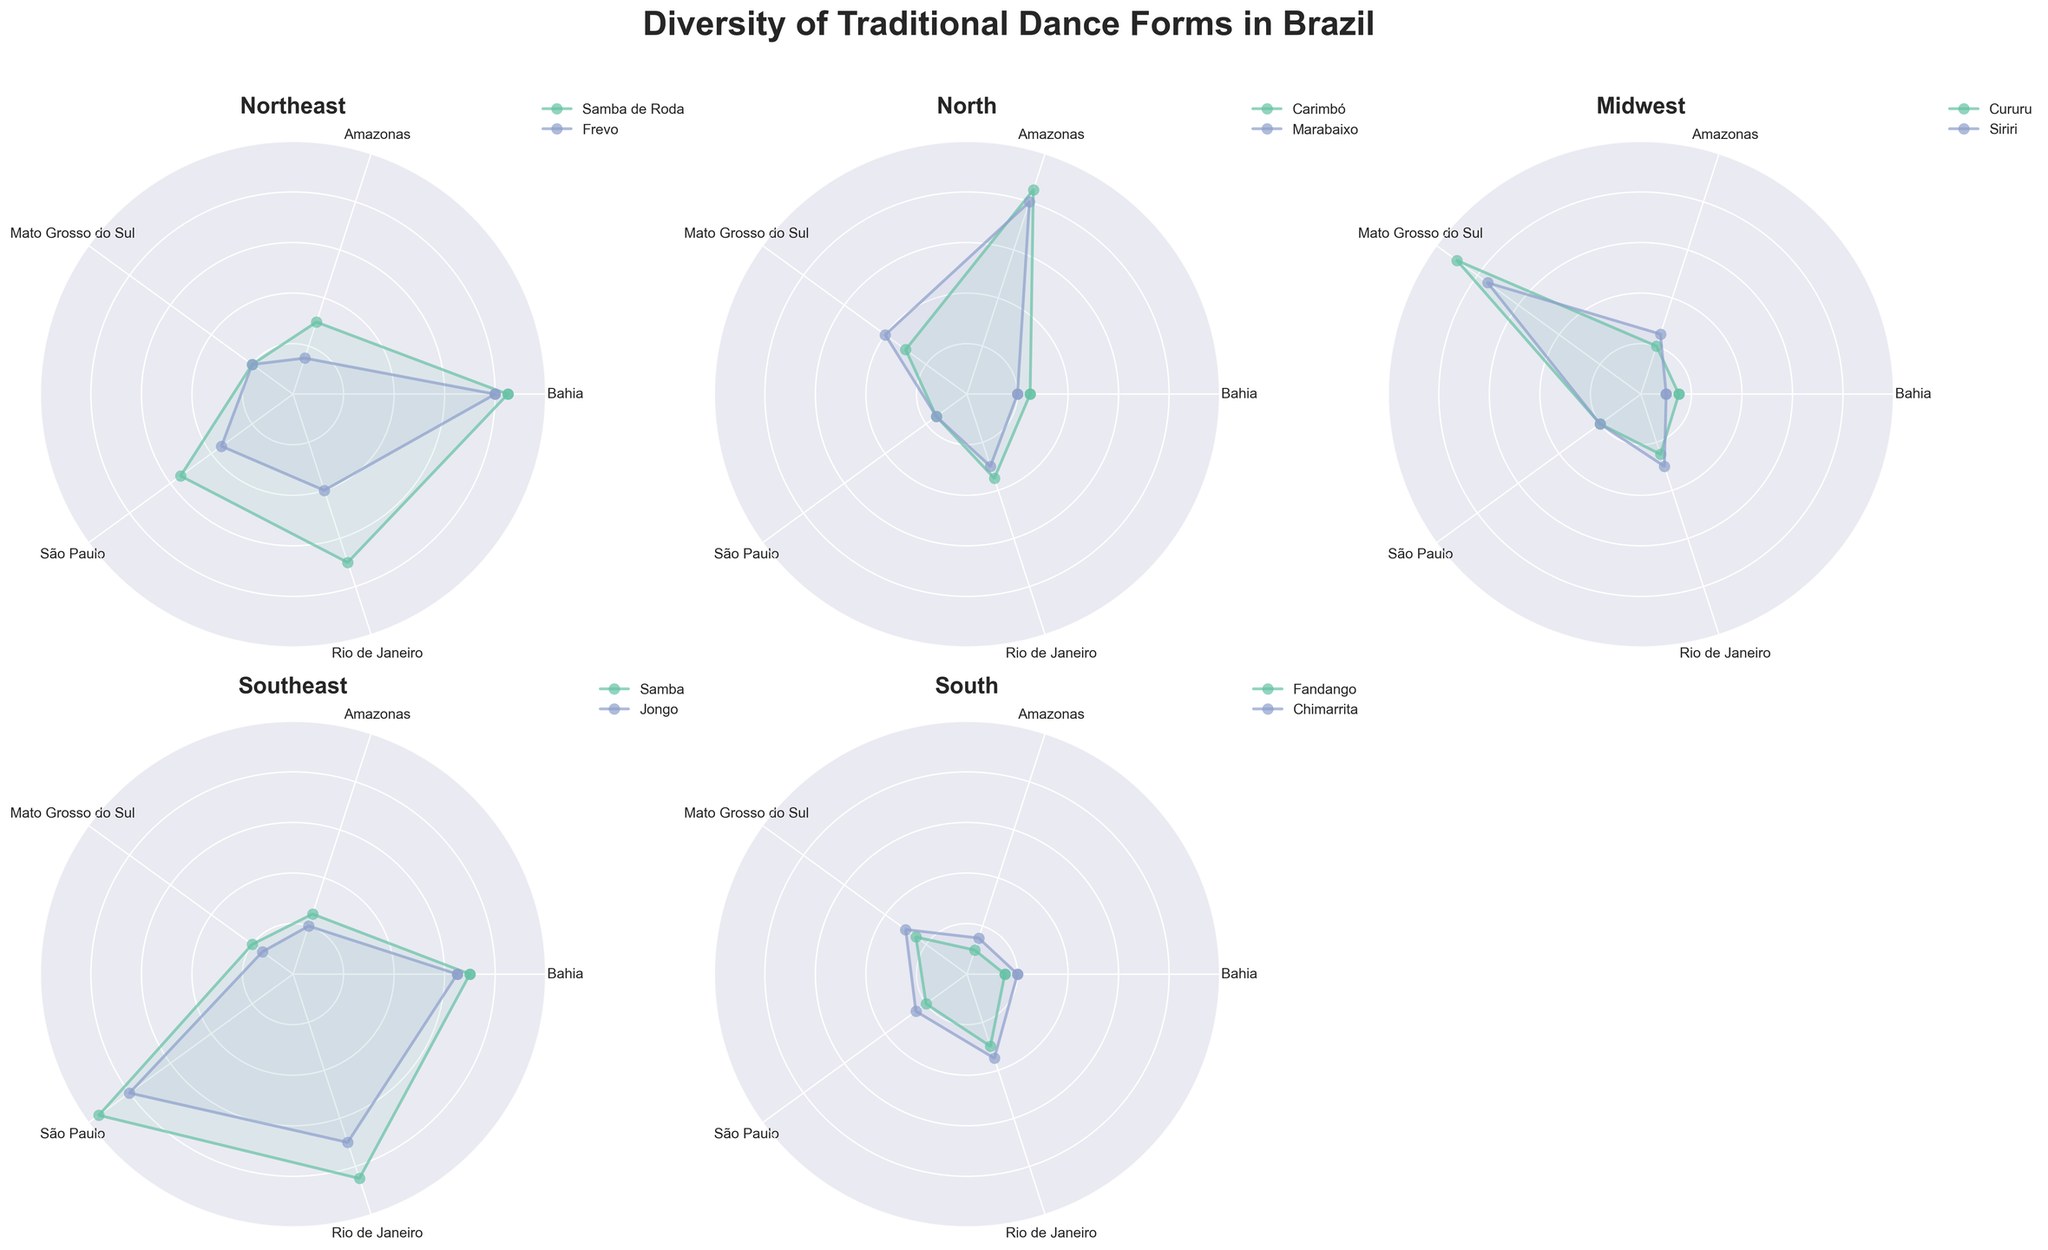What is the title of the figure? The title is usually found at the top center of the figure and is set to give an idea about the content of the plot. The title reads 'Diversity of Traditional Dance Forms in Brazil'.
Answer: Diversity of Traditional Dance Forms in Brazil Which region has the highest participation rate for Carimbó? By examining the subplot for the North region, we look at the values for each state. The highest value for Carimbó is in Amazonas at 85.
Answer: Amazonas In which state does Siriri have the highest participation rate? By checking the subplot for the Midwest region for Siriri dance, we observe the values across different states. Mato Grosso do Sul has the highest participation rate with a value of 75.
Answer: Mato Grosso do Sul How does the participation rate of Samba in São Paulo compare to that in Rio de Janeiro? Comparing the values for Samba under the Southeast region subplot, we see São Paulo has a value of 95 and Rio de Janeiro has 85. São Paulo's rate is higher than Rio de Janeiro's.
Answer: São Paulo's rate is higher Which dance has the overall lowest participation rate in the South region? Looking at the South region subplot, Fandango and Chimarrita's participation rates are compared. Fandango has values ranging from 10 to 30, while Chimarrita ranges from 15 to 35. The lowest single value is 10 for Fandango in Amazonas.
Answer: Fandango What can be inferred about the popularity of Samba de Roda across the states? Samba de Roda is part of the Northeast region. By checking values in the subplot, it appears in all states with varying participation rates: Bahia (85), Amazonas (30), Mato Grosso do Sul (20), São Paulo (55), and Rio de Janeiro (70). The popularity is highest in Bahia and varies across the other states.
Answer: Most popular in Bahia, varies in other states What is the average participation rate of Marabaixo in the shown states? Marabaixo appears under the North region. Summing the participation rates across the states: 20 (Bahia) + 80 (Amazonas) + 40 (Mato Grosso do Sul) + 15 (São Paulo) + 30 (Rio de Janeiro) = 185. The average is 185 / 5 = 37.
Answer: 37 Which dance form sees the highest participation in a single state? We compare the highest numbers for each dance across all states in respective plots. Cururu in Mato Grosso do Sul has a value of 90, Samba in São Paulo has 95. 95 is the highest single participation rate observed.
Answer: Samba in São Paulo What region includes Jongo, and how does its average participation rate compare to Samba de Roda? Jongo is in the Southeast region, and Samba de Roda in the Northeast region. Average for Jongo: (65 + 20 + 15 + 80 + 70) / 5 = 50. Average for Samba de Roda: (85 + 30 + 20 + 55 + 70) / 5 = 52. Jongo’s average is 50 and Samba de Roda is 52.
Answer: Samba de Roda has a slightly higher average Which region has the least diversity in dance forms based on the number of different dances shown? By counting the number of unique dances in each subplot: Northeast (2), North (2), Midwest (2), Southeast (2), South (2). All regions shown have an equal number of unique dances, which is 2.
Answer: All regions have equal diversity 